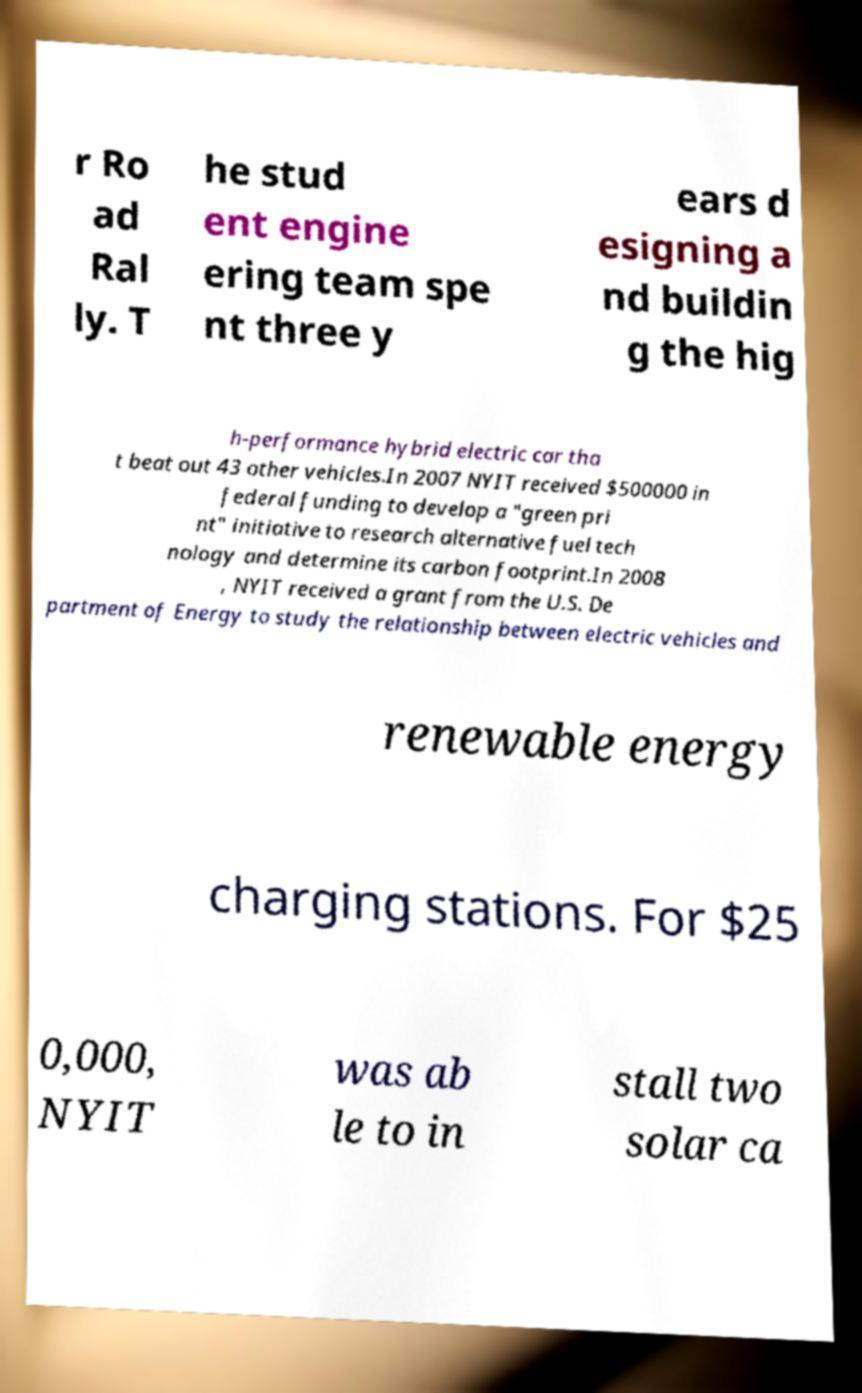Could you extract and type out the text from this image? r Ro ad Ral ly. T he stud ent engine ering team spe nt three y ears d esigning a nd buildin g the hig h-performance hybrid electric car tha t beat out 43 other vehicles.In 2007 NYIT received $500000 in federal funding to develop a "green pri nt" initiative to research alternative fuel tech nology and determine its carbon footprint.In 2008 , NYIT received a grant from the U.S. De partment of Energy to study the relationship between electric vehicles and renewable energy charging stations. For $25 0,000, NYIT was ab le to in stall two solar ca 